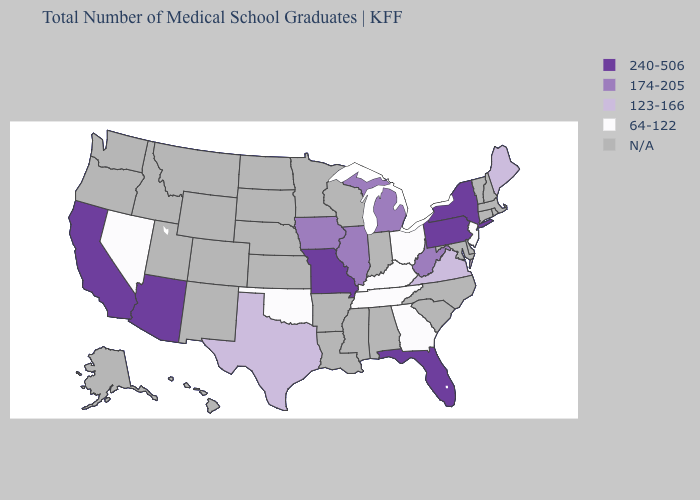What is the value of Alabama?
Quick response, please. N/A. What is the highest value in the USA?
Answer briefly. 240-506. Among the states that border New Mexico , which have the lowest value?
Concise answer only. Oklahoma. What is the value of South Carolina?
Quick response, please. N/A. Name the states that have a value in the range 64-122?
Give a very brief answer. Georgia, Kentucky, Nevada, New Jersey, Ohio, Oklahoma, Tennessee. Name the states that have a value in the range 240-506?
Keep it brief. Arizona, California, Florida, Missouri, New York, Pennsylvania. Which states hav the highest value in the MidWest?
Answer briefly. Missouri. What is the lowest value in the USA?
Short answer required. 64-122. What is the highest value in the MidWest ?
Give a very brief answer. 240-506. What is the highest value in states that border Arkansas?
Short answer required. 240-506. Among the states that border South Dakota , which have the lowest value?
Quick response, please. Iowa. Name the states that have a value in the range 174-205?
Give a very brief answer. Illinois, Iowa, Michigan, West Virginia. Name the states that have a value in the range 123-166?
Answer briefly. Maine, Texas, Virginia. Among the states that border Illinois , which have the lowest value?
Keep it brief. Kentucky. 